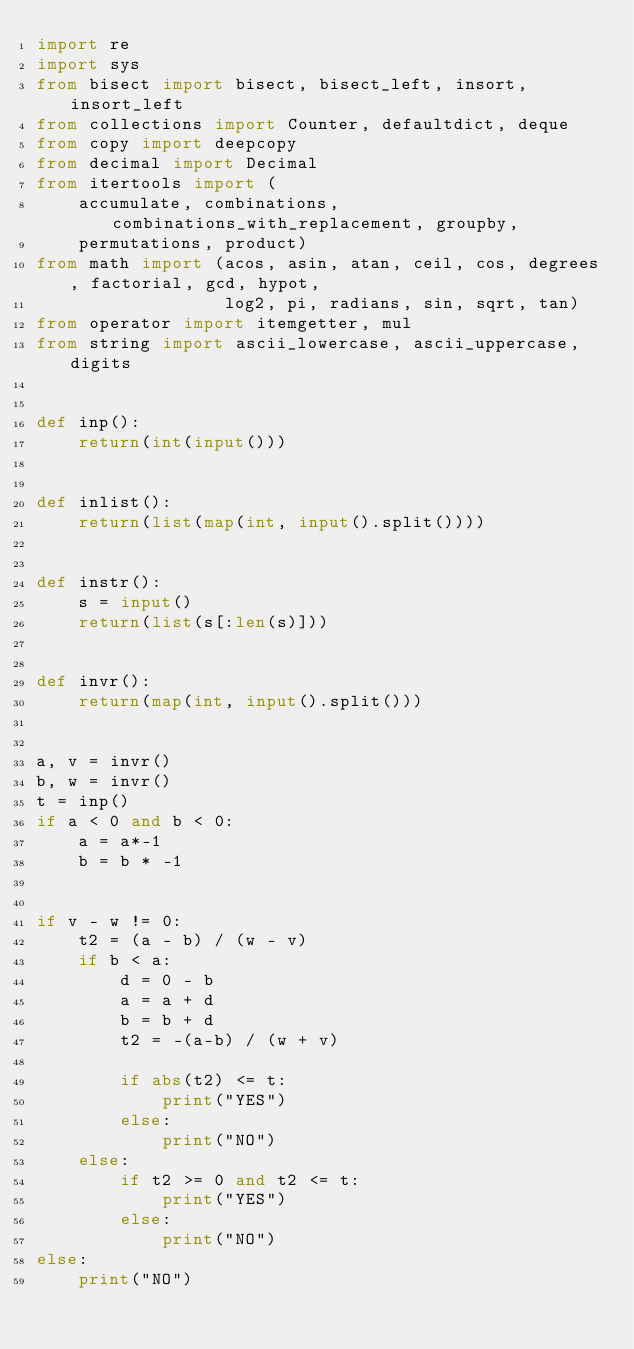Convert code to text. <code><loc_0><loc_0><loc_500><loc_500><_Python_>import re
import sys
from bisect import bisect, bisect_left, insort, insort_left
from collections import Counter, defaultdict, deque
from copy import deepcopy
from decimal import Decimal
from itertools import (
    accumulate, combinations, combinations_with_replacement, groupby,
    permutations, product)
from math import (acos, asin, atan, ceil, cos, degrees, factorial, gcd, hypot,
                  log2, pi, radians, sin, sqrt, tan)
from operator import itemgetter, mul
from string import ascii_lowercase, ascii_uppercase, digits


def inp():
    return(int(input()))


def inlist():
    return(list(map(int, input().split())))


def instr():
    s = input()
    return(list(s[:len(s)]))


def invr():
    return(map(int, input().split()))


a, v = invr()
b, w = invr()
t = inp()
if a < 0 and b < 0:
    a = a*-1
    b = b * -1


if v - w != 0:
    t2 = (a - b) / (w - v)
    if b < a:
        d = 0 - b
        a = a + d 
        b = b + d
        t2 = -(a-b) / (w + v)

        if abs(t2) <= t:
            print("YES")
        else:
            print("NO")
    else:
        if t2 >= 0 and t2 <= t:
            print("YES")
        else:
            print("NO")
else:
    print("NO")
</code> 